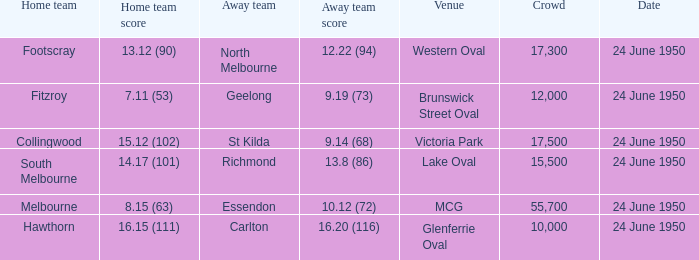When was the event where the away team achieved a score of 1 24 June 1950. 